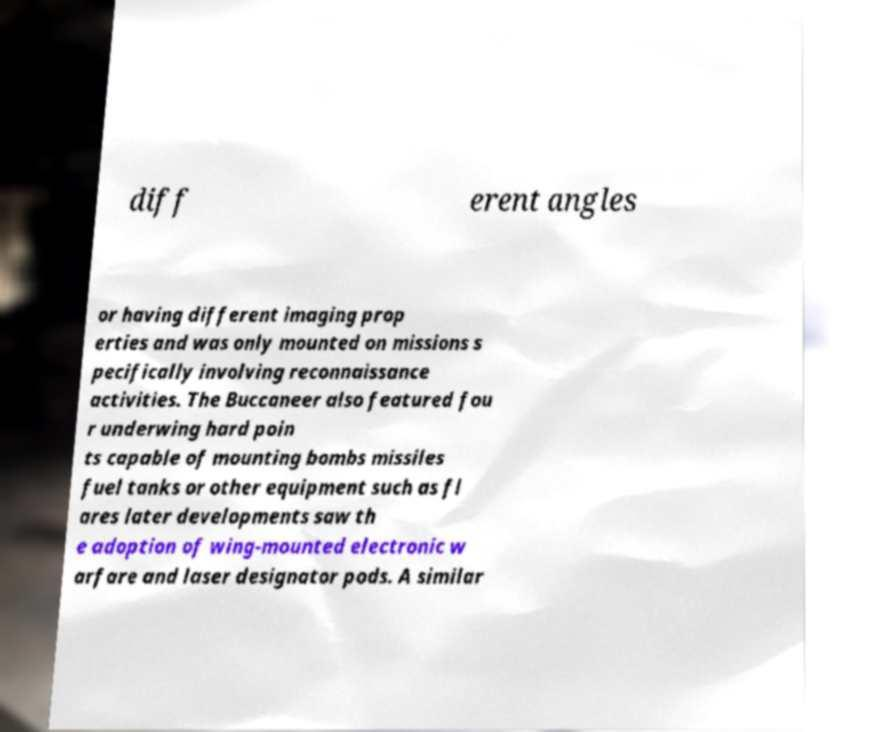Could you extract and type out the text from this image? diff erent angles or having different imaging prop erties and was only mounted on missions s pecifically involving reconnaissance activities. The Buccaneer also featured fou r underwing hard poin ts capable of mounting bombs missiles fuel tanks or other equipment such as fl ares later developments saw th e adoption of wing-mounted electronic w arfare and laser designator pods. A similar 